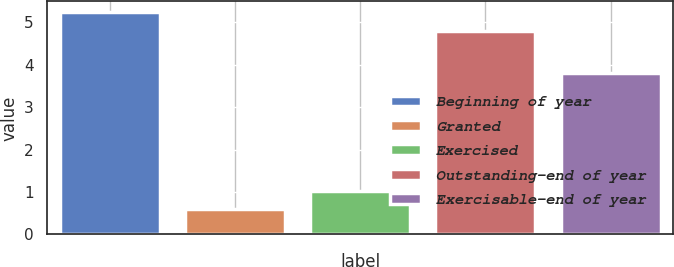Convert chart. <chart><loc_0><loc_0><loc_500><loc_500><bar_chart><fcel>Beginning of year<fcel>Granted<fcel>Exercised<fcel>Outstanding-end of year<fcel>Exercisable-end of year<nl><fcel>5.23<fcel>0.6<fcel>1.03<fcel>4.8<fcel>3.8<nl></chart> 